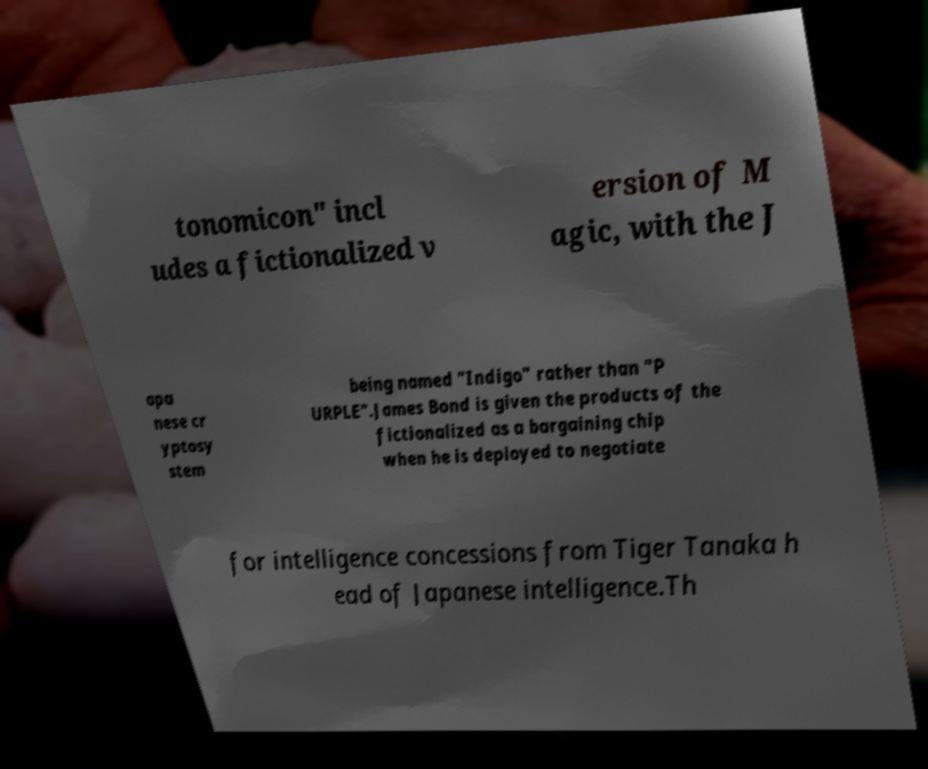There's text embedded in this image that I need extracted. Can you transcribe it verbatim? tonomicon" incl udes a fictionalized v ersion of M agic, with the J apa nese cr yptosy stem being named "Indigo" rather than "P URPLE".James Bond is given the products of the fictionalized as a bargaining chip when he is deployed to negotiate for intelligence concessions from Tiger Tanaka h ead of Japanese intelligence.Th 